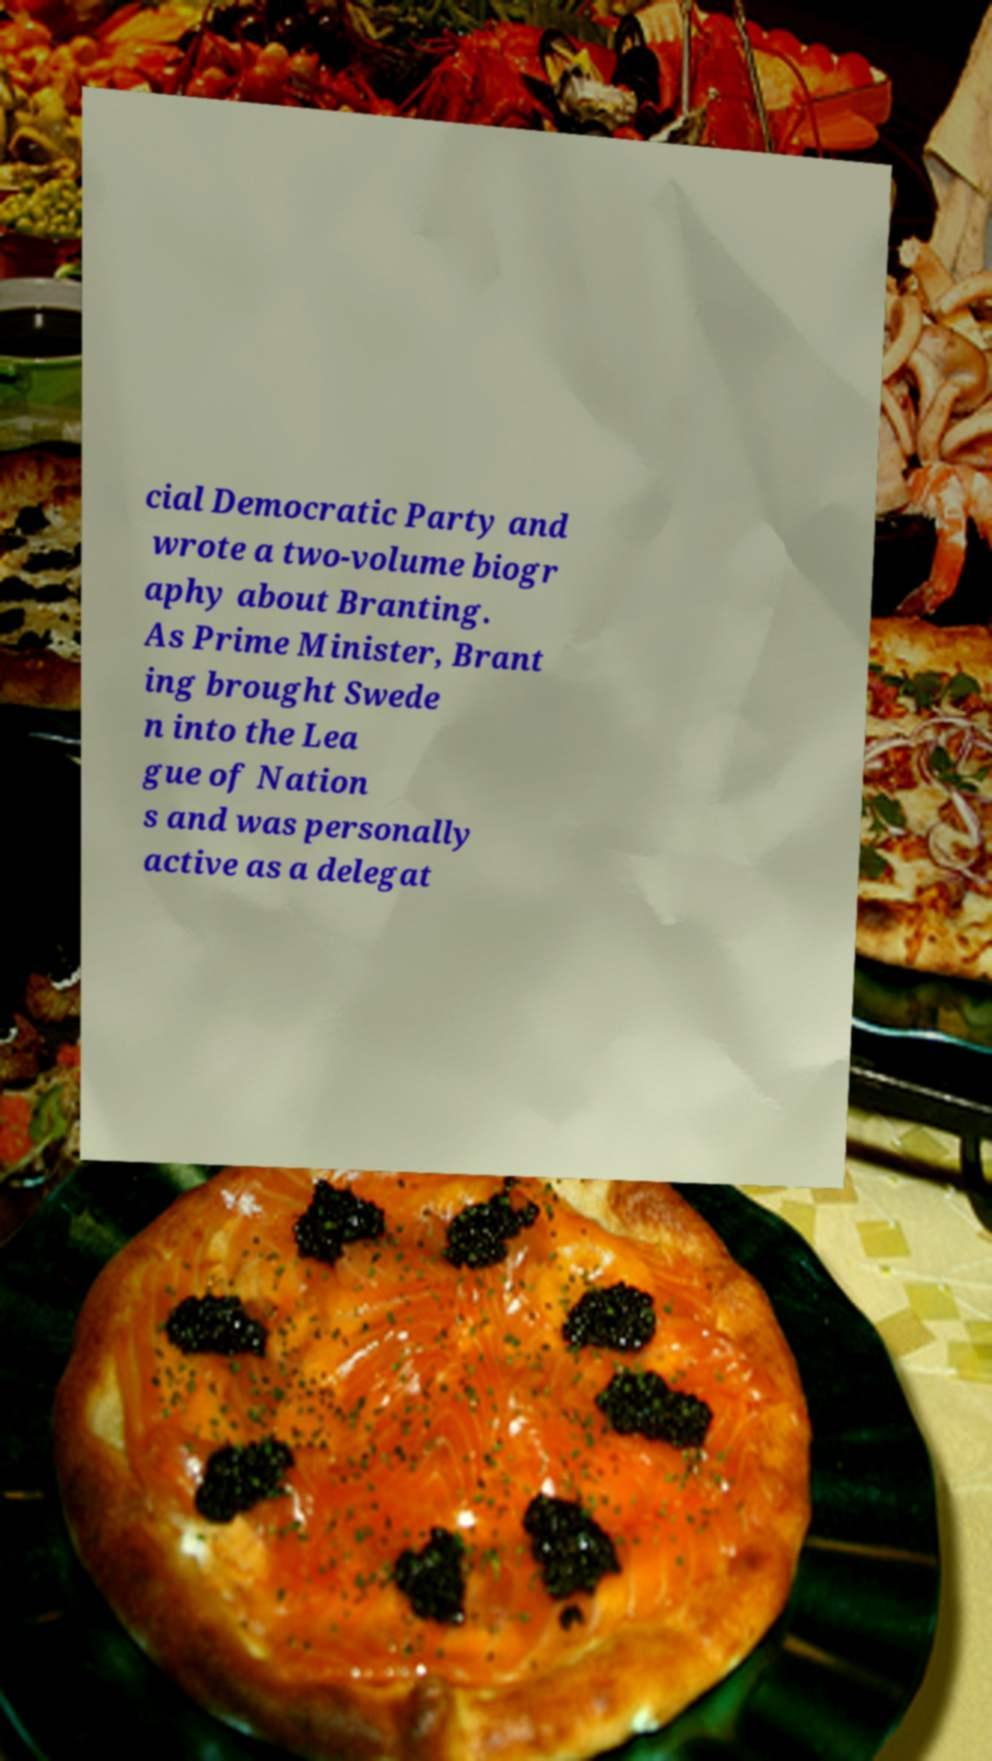Please identify and transcribe the text found in this image. cial Democratic Party and wrote a two-volume biogr aphy about Branting. As Prime Minister, Brant ing brought Swede n into the Lea gue of Nation s and was personally active as a delegat 